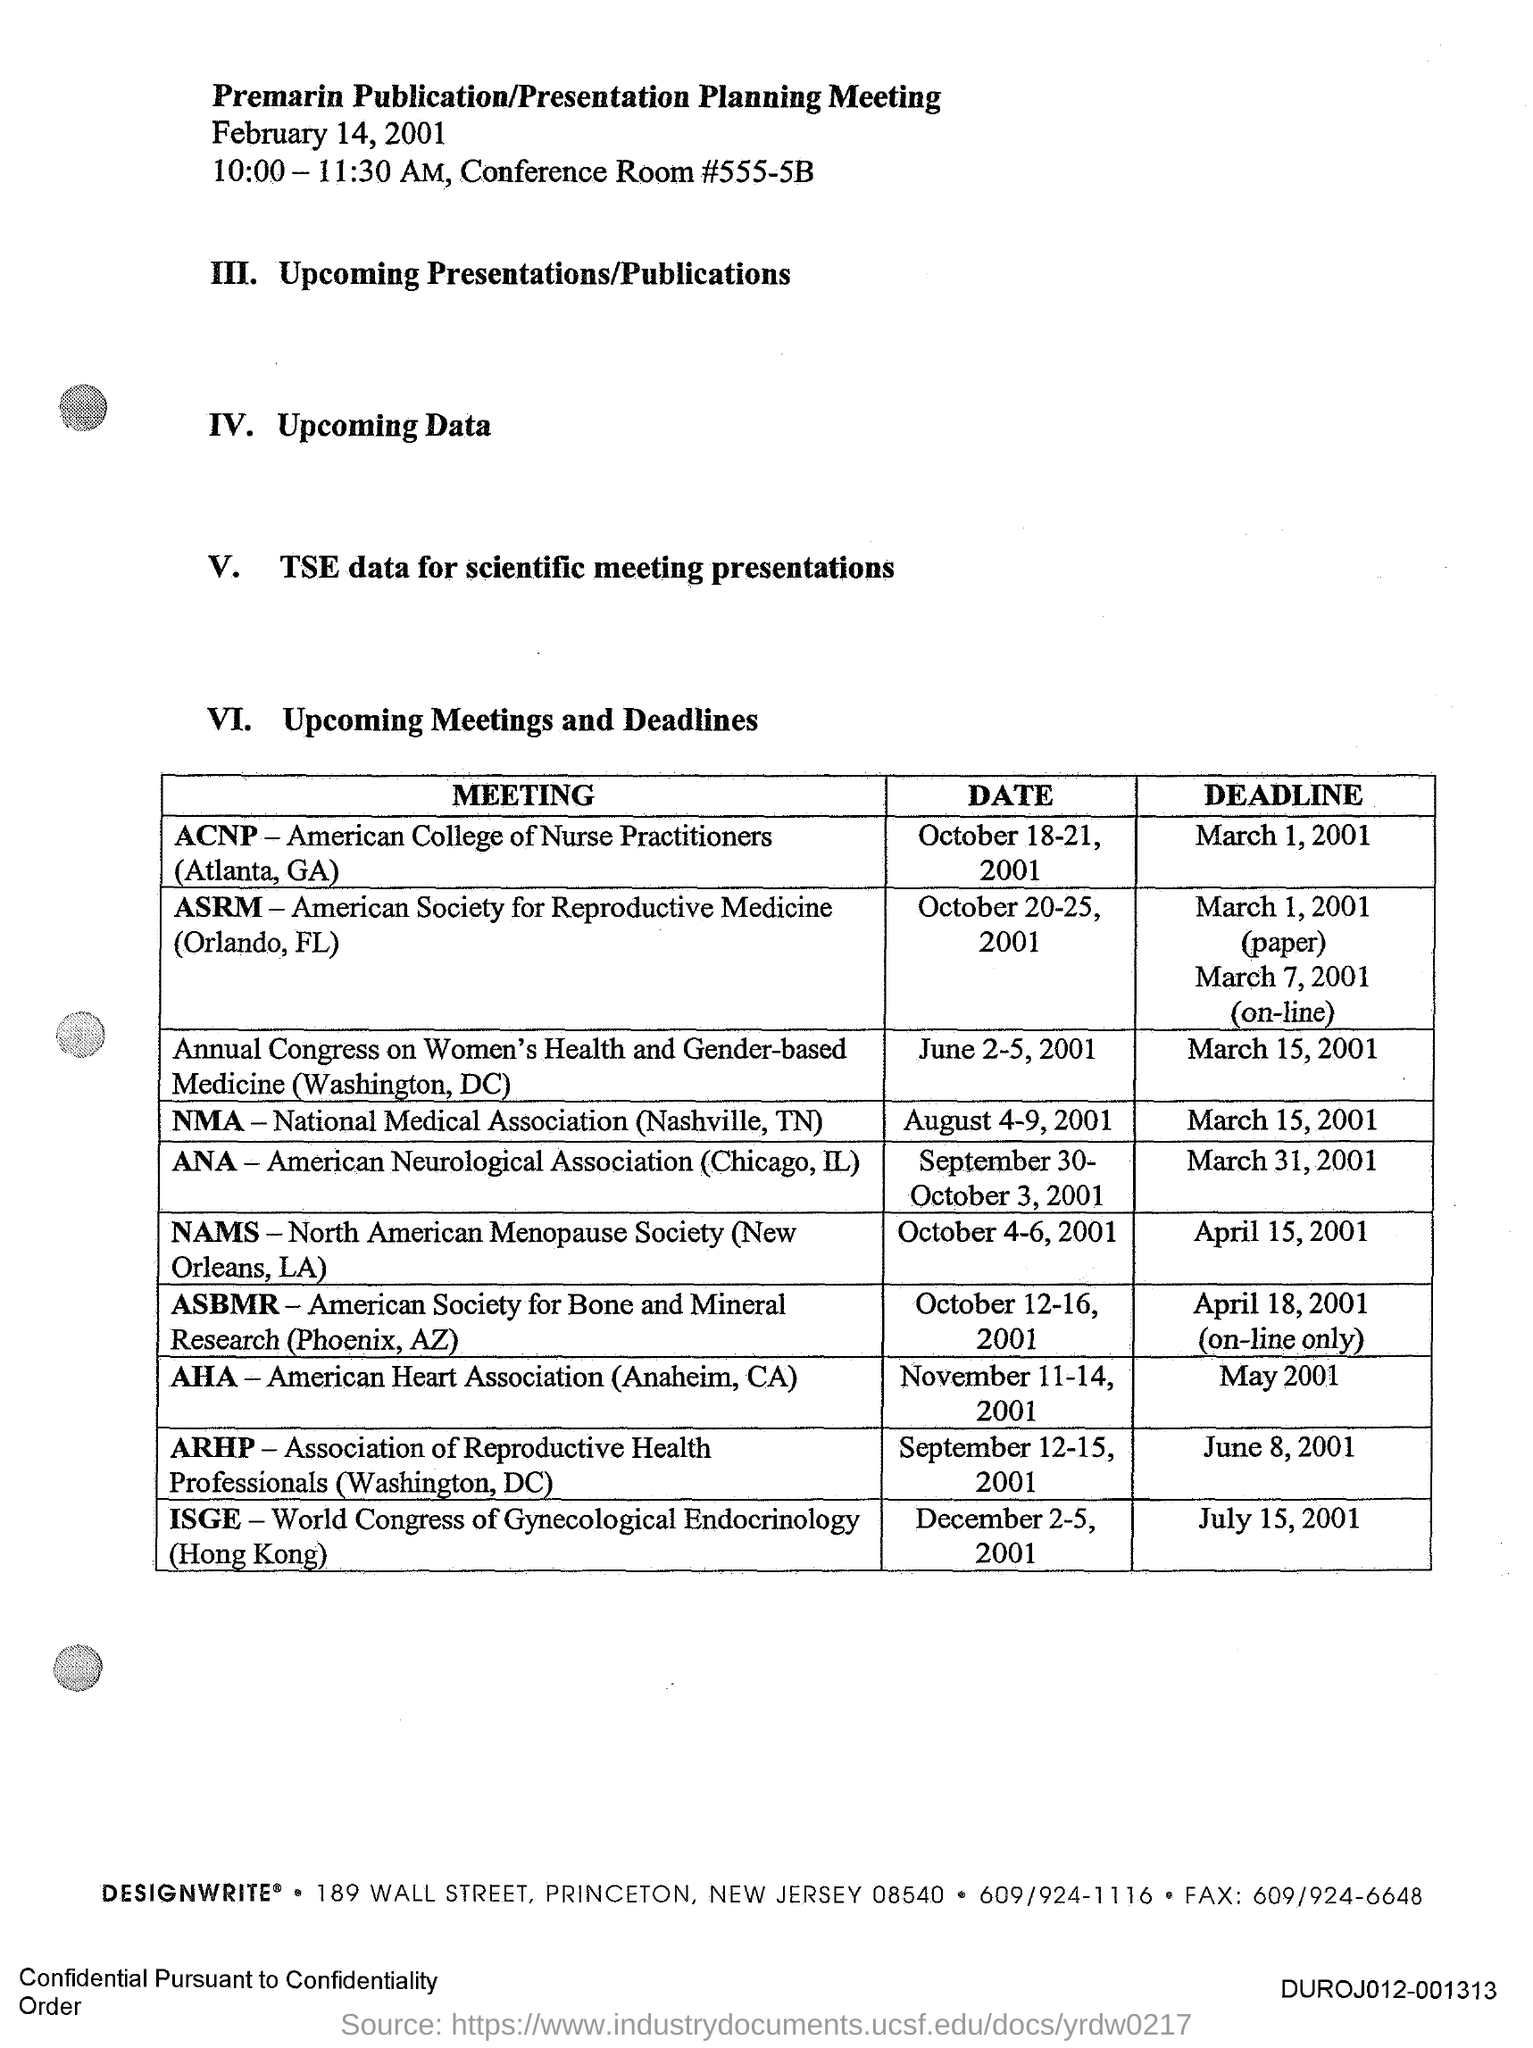Highlight a few significant elements in this photo. The meeting date of the ANA (Chicago, IL) is from SEPTEMBER 30 to OCTOBER 3, 2001. The deadline for the AHA (Anaheim, CA) meeting is MAY 2001. The deadline for the ISGE (Hongkong) meeting is July 15, 2001. The Premarin Publication/Presentation Planning Meeting is scheduled to take place on February 14, 2001, from 10:00-11:30 AM. The acronym "AHA" stands for "American Heart Association. 